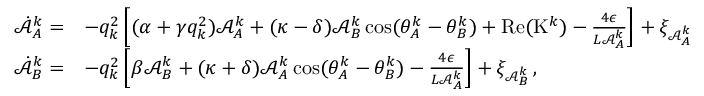Convert formula to latex. <formula><loc_0><loc_0><loc_500><loc_500>\begin{array} { r l } { \dot { \mathcal { A } } _ { A } ^ { k } = } & { - q _ { k } ^ { 2 } \left [ ( \alpha + \gamma q _ { k } ^ { 2 } ) \mathcal { A } _ { A } ^ { k } + ( \kappa - \delta ) \mathcal { A } _ { B } ^ { k } \cos ( \theta _ { A } ^ { k } - \theta _ { B } ^ { k } ) + R e ( K ^ { k } ) - \frac { 4 \epsilon } { L \mathcal { A } _ { A } ^ { k } } \right ] + \xi _ { \mathcal { A } _ { A } ^ { k } } } \\ { \dot { \mathcal { A } } _ { B } ^ { k } = } & { - q _ { k } ^ { 2 } \left [ \beta \mathcal { A } _ { B } ^ { k } + ( \kappa + \delta ) \mathcal { A } _ { A } ^ { k } \cos ( \theta _ { A } ^ { k } - \theta _ { B } ^ { k } ) - \frac { 4 \epsilon } { L \mathcal { A } _ { A } ^ { k } } \right ] + \xi _ { \mathcal { A } _ { B } ^ { k } } \, , } \end{array}</formula> 